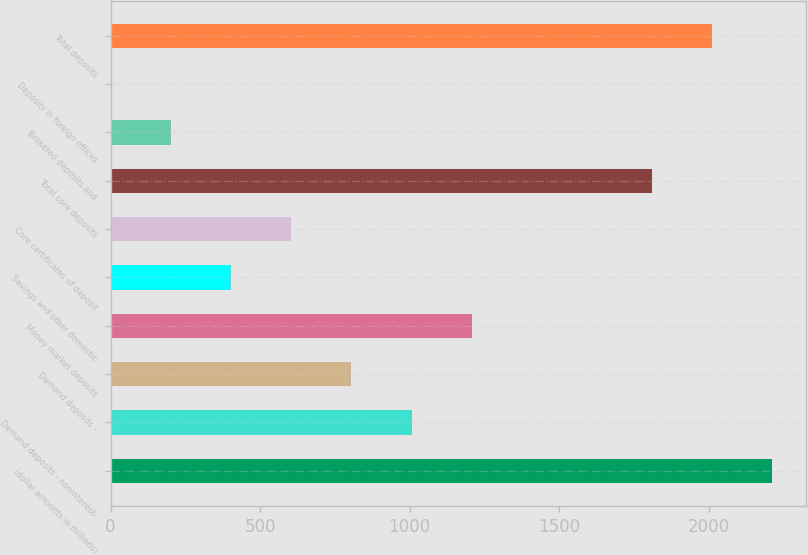Convert chart to OTSL. <chart><loc_0><loc_0><loc_500><loc_500><bar_chart><fcel>(dollar amounts in millions)<fcel>Demand deposits - noninterest-<fcel>Demand deposits -<fcel>Money market deposits<fcel>Savings and other domestic<fcel>Core certificates of deposit<fcel>Total core deposits<fcel>Brokered deposits and<fcel>Deposits in foreign offices<fcel>Total deposits<nl><fcel>2213.1<fcel>1006.5<fcel>805.4<fcel>1207.6<fcel>403.2<fcel>604.3<fcel>1810.9<fcel>202.1<fcel>1<fcel>2012<nl></chart> 